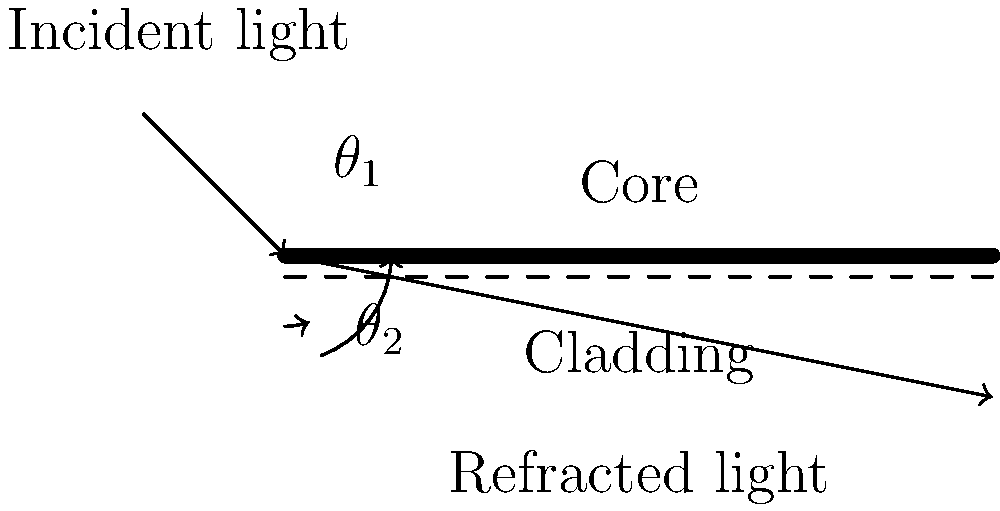In fiber optic data transmission, light travels through the core of the cable by total internal reflection. Given that the refractive index of the core is 1.5 and the refractive index of the cladding is 1.48, what is the critical angle for total internal reflection to occur? How does this relate to the maximum angle at which data can be transmitted efficiently through the fiber? To solve this problem, we'll follow these steps:

1. Recall Snell's law: $n_1 \sin(\theta_1) = n_2 \sin(\theta_2)$
   Where $n_1$ is the refractive index of the core, $n_2$ is the refractive index of the cladding, $\theta_1$ is the angle of incidence, and $\theta_2$ is the angle of refraction.

2. For total internal reflection, the critical angle occurs when the angle of refraction is 90°. At this point, $\sin(\theta_2) = \sin(90°) = 1$.

3. Substituting into Snell's law:
   $n_1 \sin(\theta_c) = n_2 \sin(90°)$
   $n_1 \sin(\theta_c) = n_2$

4. Solve for the critical angle $\theta_c$:
   $\sin(\theta_c) = \frac{n_2}{n_1}$
   $\theta_c = \arcsin(\frac{n_2}{n_1})$

5. Plug in the values:
   $\theta_c = \arcsin(\frac{1.48}{1.5})$

6. Calculate:
   $\theta_c \approx 80.6°$

7. The maximum angle at which data can be transmitted efficiently is related to the complement of the critical angle, known as the acceptance angle. This is because any light entering the fiber at an angle greater than this will not undergo total internal reflection and will be lost through the cladding.

8. The acceptance angle $\theta_a$ is given by:
   $\theta_a = 90° - \theta_c \approx 9.4°$

This acceptance angle determines the numerical aperture of the fiber, which is a measure of its light-gathering ability and affects the fiber's data transmission capacity.
Answer: Critical angle: $80.6°$; Acceptance angle: $9.4°$ 